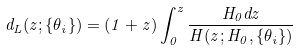<formula> <loc_0><loc_0><loc_500><loc_500>d _ { L } ( z ; \{ \theta _ { i } \} ) = ( 1 + z ) \int _ { 0 } ^ { z } \frac { H _ { 0 } d z } { H ( z ; H _ { 0 } , \{ \theta _ { i } \} ) }</formula> 